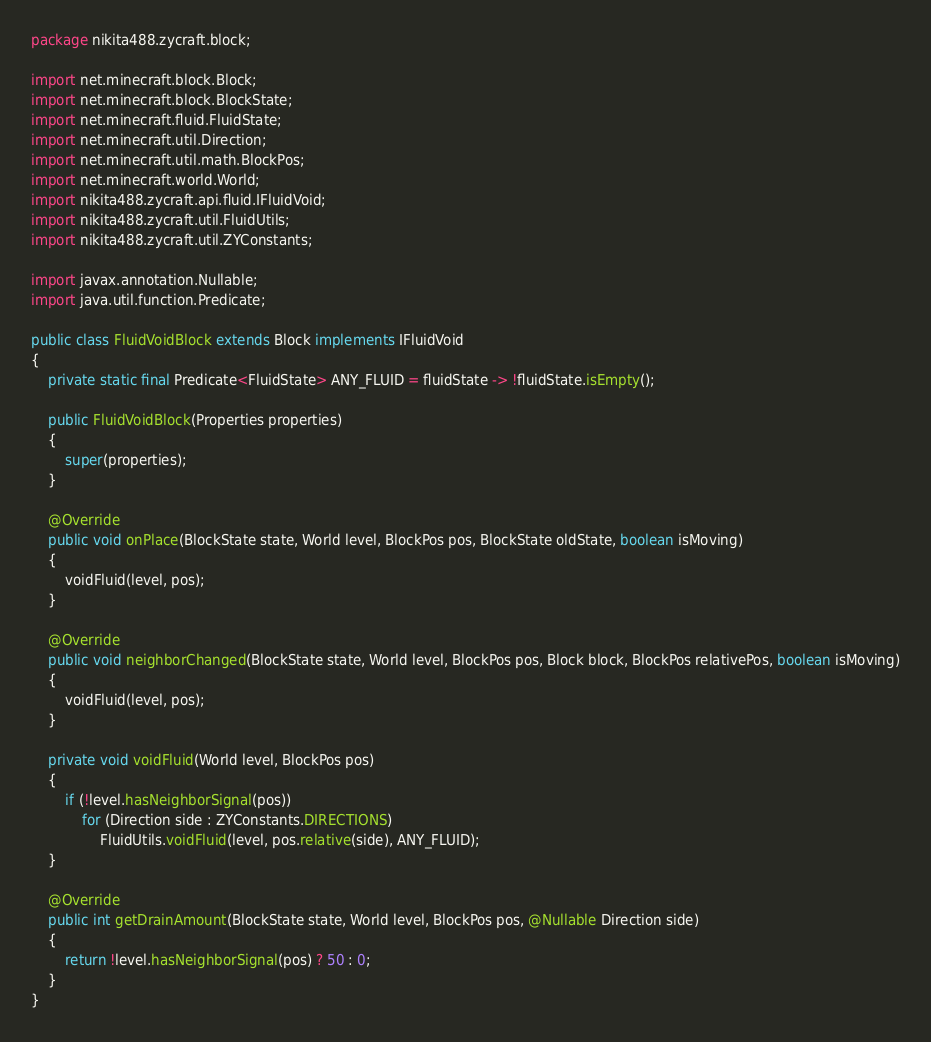<code> <loc_0><loc_0><loc_500><loc_500><_Java_>package nikita488.zycraft.block;

import net.minecraft.block.Block;
import net.minecraft.block.BlockState;
import net.minecraft.fluid.FluidState;
import net.minecraft.util.Direction;
import net.minecraft.util.math.BlockPos;
import net.minecraft.world.World;
import nikita488.zycraft.api.fluid.IFluidVoid;
import nikita488.zycraft.util.FluidUtils;
import nikita488.zycraft.util.ZYConstants;

import javax.annotation.Nullable;
import java.util.function.Predicate;

public class FluidVoidBlock extends Block implements IFluidVoid
{
    private static final Predicate<FluidState> ANY_FLUID = fluidState -> !fluidState.isEmpty();

    public FluidVoidBlock(Properties properties)
    {
        super(properties);
    }

    @Override
    public void onPlace(BlockState state, World level, BlockPos pos, BlockState oldState, boolean isMoving)
    {
        voidFluid(level, pos);
    }

    @Override
    public void neighborChanged(BlockState state, World level, BlockPos pos, Block block, BlockPos relativePos, boolean isMoving)
    {
        voidFluid(level, pos);
    }

    private void voidFluid(World level, BlockPos pos)
    {
        if (!level.hasNeighborSignal(pos))
            for (Direction side : ZYConstants.DIRECTIONS)
                FluidUtils.voidFluid(level, pos.relative(side), ANY_FLUID);
    }

    @Override
    public int getDrainAmount(BlockState state, World level, BlockPos pos, @Nullable Direction side)
    {
        return !level.hasNeighborSignal(pos) ? 50 : 0;
    }
}
</code> 